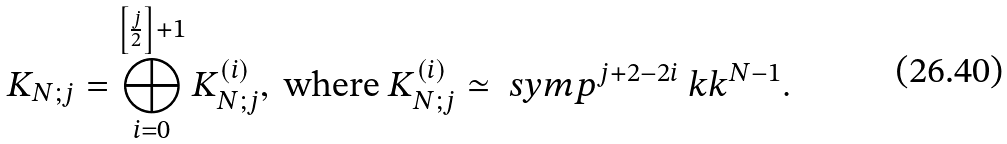Convert formula to latex. <formula><loc_0><loc_0><loc_500><loc_500>K _ { N ; j } = \bigoplus ^ { \left [ \frac { j } { 2 } \right ] + 1 } _ { i = 0 } K ^ { ( i ) } _ { N ; j } , \text { where } K ^ { ( i ) } _ { N ; j } \simeq \ s y m p ^ { j + 2 - 2 i } \ k k ^ { N - 1 } .</formula> 